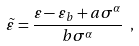<formula> <loc_0><loc_0><loc_500><loc_500>\tilde { \varepsilon } = \frac { \varepsilon - \varepsilon _ { b } + a \sigma ^ { \alpha } } { b \sigma ^ { \alpha } } \ ,</formula> 